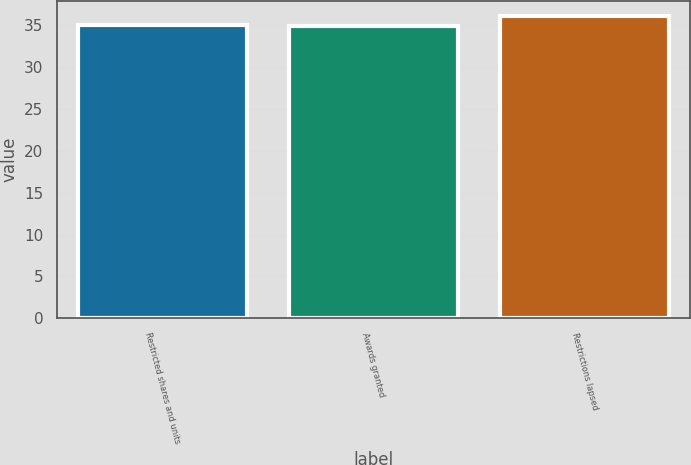Convert chart to OTSL. <chart><loc_0><loc_0><loc_500><loc_500><bar_chart><fcel>Restricted shares and units<fcel>Awards granted<fcel>Restrictions lapsed<nl><fcel>35.01<fcel>34.89<fcel>36.12<nl></chart> 